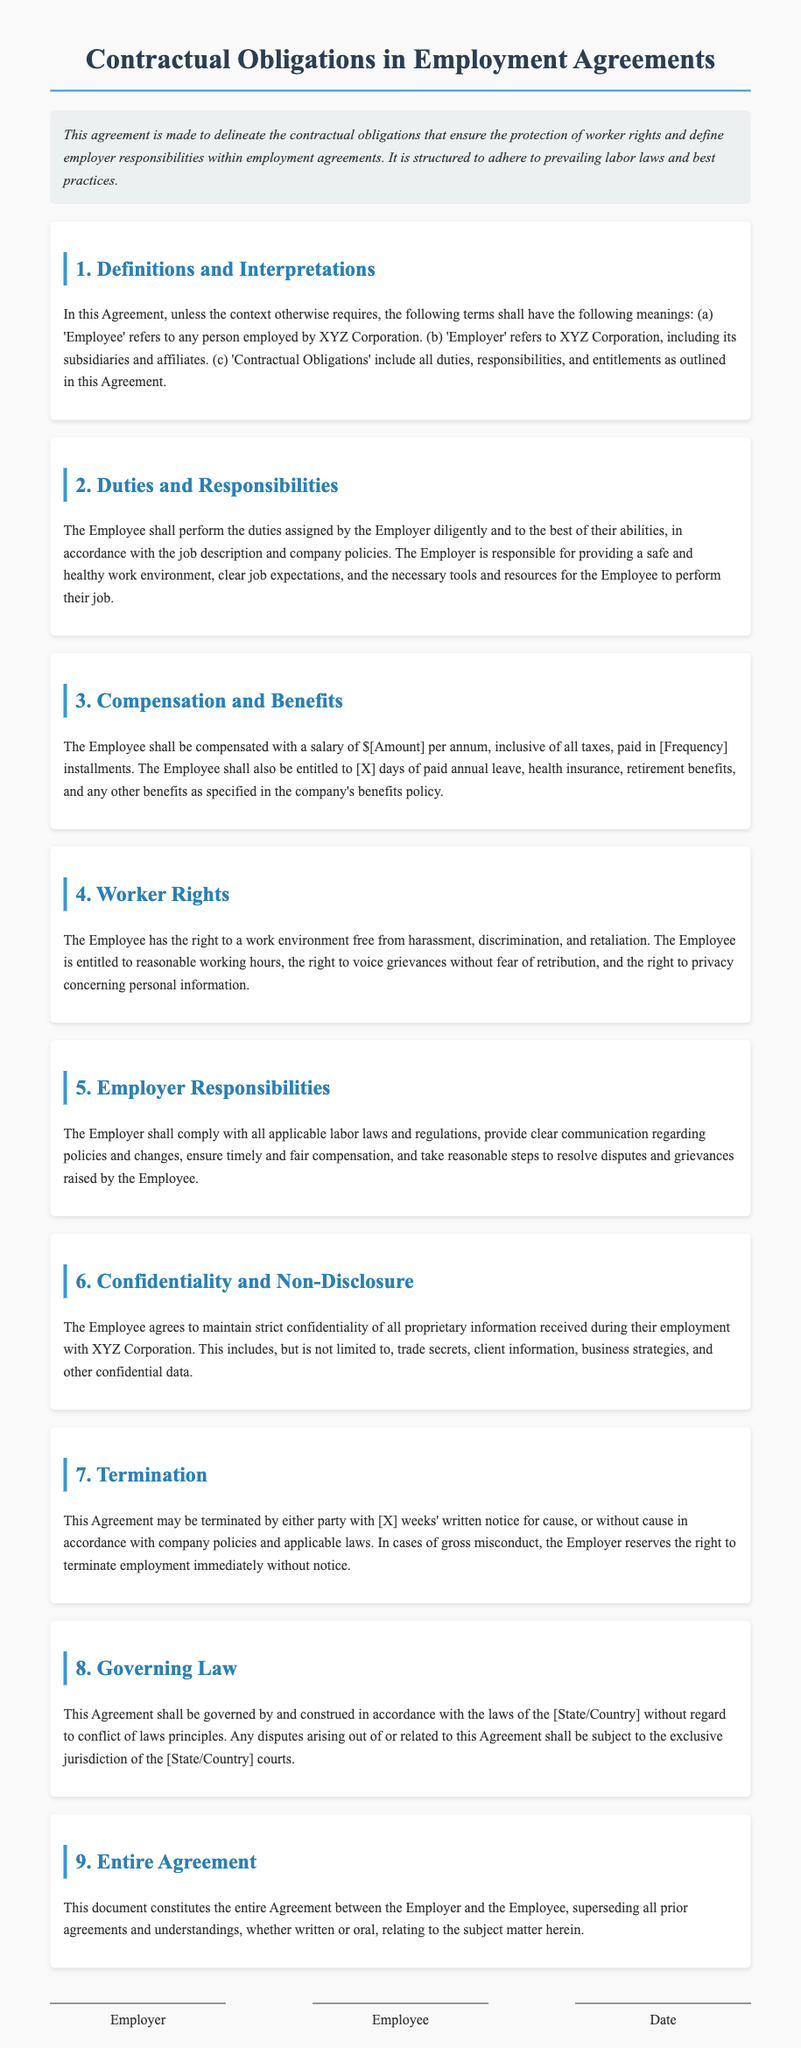What is the title of the document? The title is stated at the top of the document, which defines the content covered.
Answer: Contractual Obligations in Employment Agreements Who is referred to as the 'Employer'? This term is defined in the document specifying the entity responsible in the agreement.
Answer: XYZ Corporation What is the salary of the Employee? The salary is mentioned as part of the compensation and benefits section, though a specific number is not provided in the text.
Answer: $[Amount] How many days of paid annual leave is the Employee entitled to? This information is included in the compensation and benefits section, specifying the Employee's leave entitlements.
Answer: [X] days What rights does the Employee have regarding harassment? The document specifies the Employee's rights in relation to a safe work environment in one of the sections.
Answer: Free from harassment What is the required notice period for termination of the agreement? The notice period is outlined in the termination section of the document regarding how long notice must be given.
Answer: [X] weeks What type of law governs this agreement? The governing law is mentioned in the appropriate section outlining the legal framework for the agreement.
Answer: The laws of the [State/Country] Is the agreement the entire understanding between the parties? The last section of the document mentions the nature of the agreement in relation to prior agreements.
Answer: Yes 